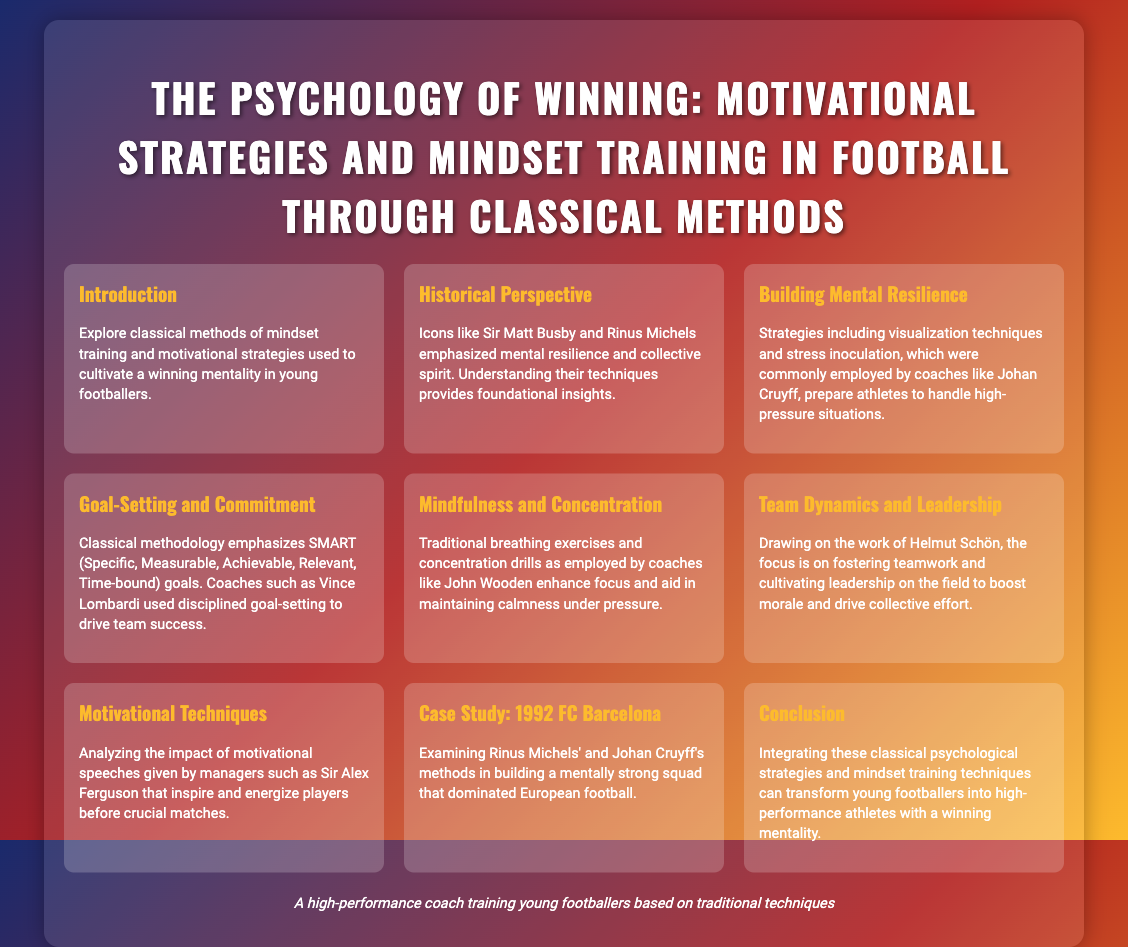what is the title of the presentation? The title of the presentation is stated prominently at the top of the document.
Answer: The Psychology of Winning: Motivational Strategies and Mindset Training in Football Through Classical Methods who emphasized mental resilience? The document mentions icons who emphasized mental resilience, specifically stating their names.
Answer: Sir Matt Busby and Rinus Michels what does SMART stand for? SMART is an acronym that is explained in the "Goal-Setting and Commitment" section of the document.
Answer: Specific, Measurable, Achievable, Relevant, Time-bound which coach used visualization techniques? The document notes that several strategies were commonly employed by coaches, specifically mentioning one associated with visualization.
Answer: Johan Cruyff what is a key technique mentioned for enhancing focus? The document describes traditional practices that enhance focus under pressure, specifically mentioning one of these practices.
Answer: Breathing exercises how did Rinus Michels contribute to football? The document highlights a case study that points to the contributions of a specific coach in building a strong team.
Answer: Building a mentally strong squad what was the main focus of Helmut Schön's work? The document summarizes the aim of Helmut Schön's contributions to football.
Answer: Fostering teamwork and cultivating leadership name one motivational technique analyzed in the presentation. The document provides an example of a specific technique regarding motivational speeches in a section.
Answer: Motivational speeches what impact do motivational speeches have according to the document? The document discusses the effect of certain speeches, providing an insight into their purpose.
Answer: Inspire and energize players 